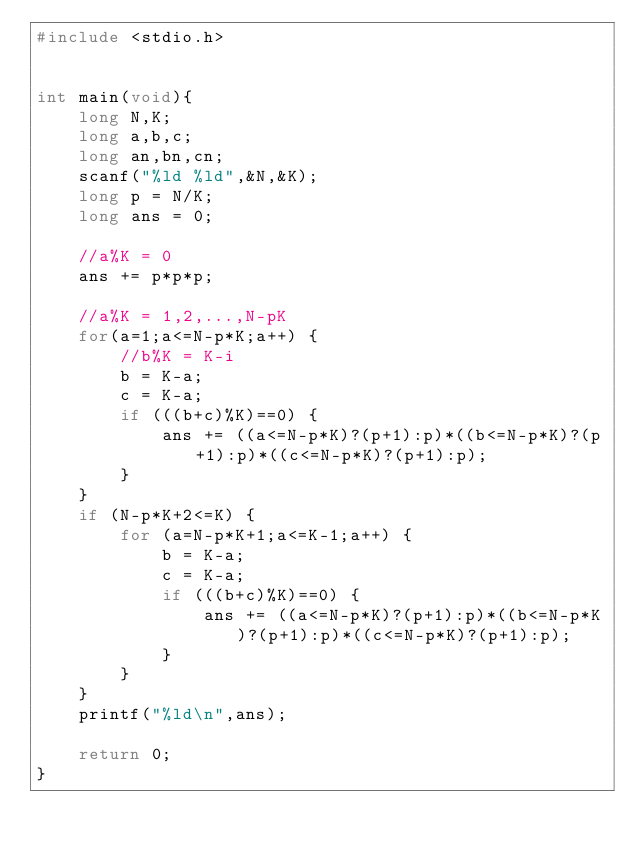<code> <loc_0><loc_0><loc_500><loc_500><_C_>#include <stdio.h>


int main(void){
	long N,K;
	long a,b,c;
	long an,bn,cn;
	scanf("%ld %ld",&N,&K);
	long p = N/K;
	long ans = 0;

	//a%K = 0
	ans += p*p*p;

	//a%K = 1,2,...,N-pK
	for(a=1;a<=N-p*K;a++) {
		//b%K = K-i
		b = K-a;
		c = K-a;
		if (((b+c)%K)==0) {
			ans += ((a<=N-p*K)?(p+1):p)*((b<=N-p*K)?(p+1):p)*((c<=N-p*K)?(p+1):p);
		}
	}
	if (N-p*K+2<=K) {
		for (a=N-p*K+1;a<=K-1;a++) {
			b = K-a;
			c = K-a;
			if (((b+c)%K)==0) {
				ans += ((a<=N-p*K)?(p+1):p)*((b<=N-p*K)?(p+1):p)*((c<=N-p*K)?(p+1):p);
			}
		}
	}
	printf("%ld\n",ans);
	
	return 0;
}
</code> 